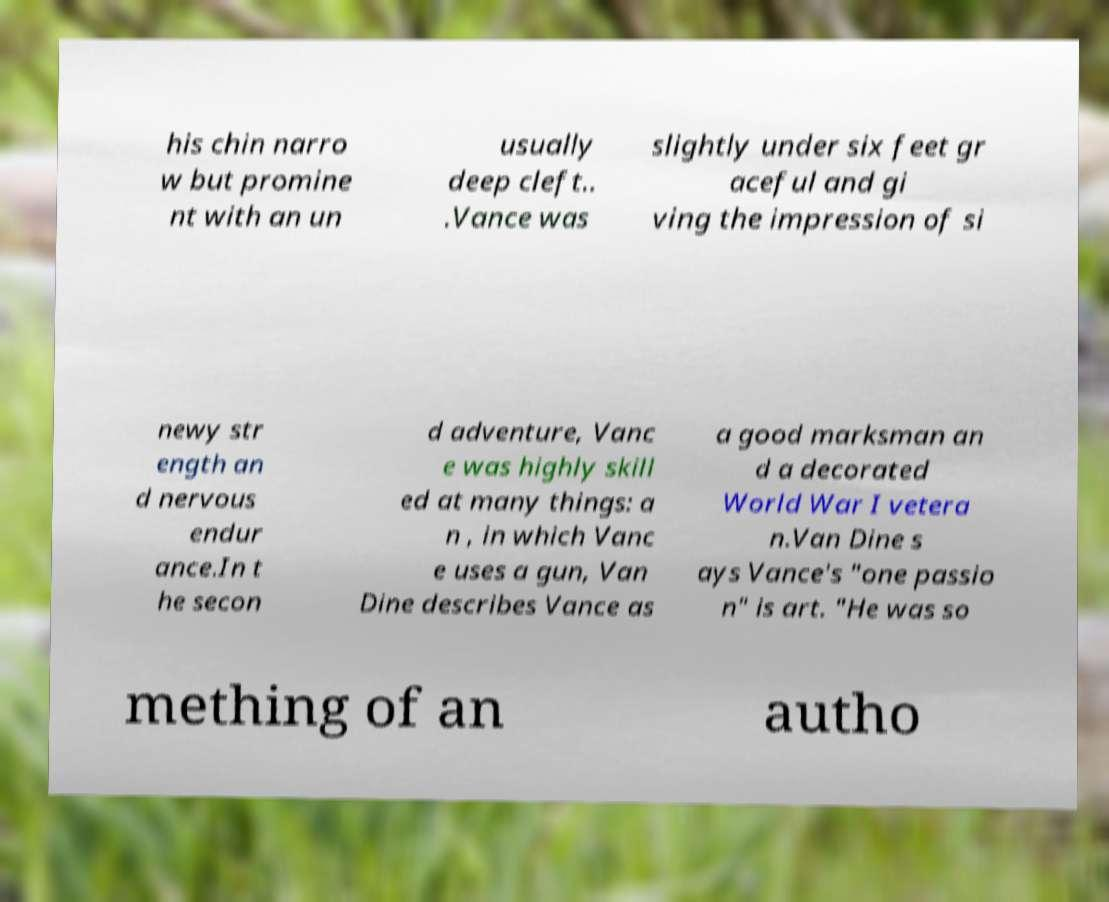There's text embedded in this image that I need extracted. Can you transcribe it verbatim? his chin narro w but promine nt with an un usually deep cleft.. .Vance was slightly under six feet gr aceful and gi ving the impression of si newy str ength an d nervous endur ance.In t he secon d adventure, Vanc e was highly skill ed at many things: a n , in which Vanc e uses a gun, Van Dine describes Vance as a good marksman an d a decorated World War I vetera n.Van Dine s ays Vance's "one passio n" is art. "He was so mething of an autho 